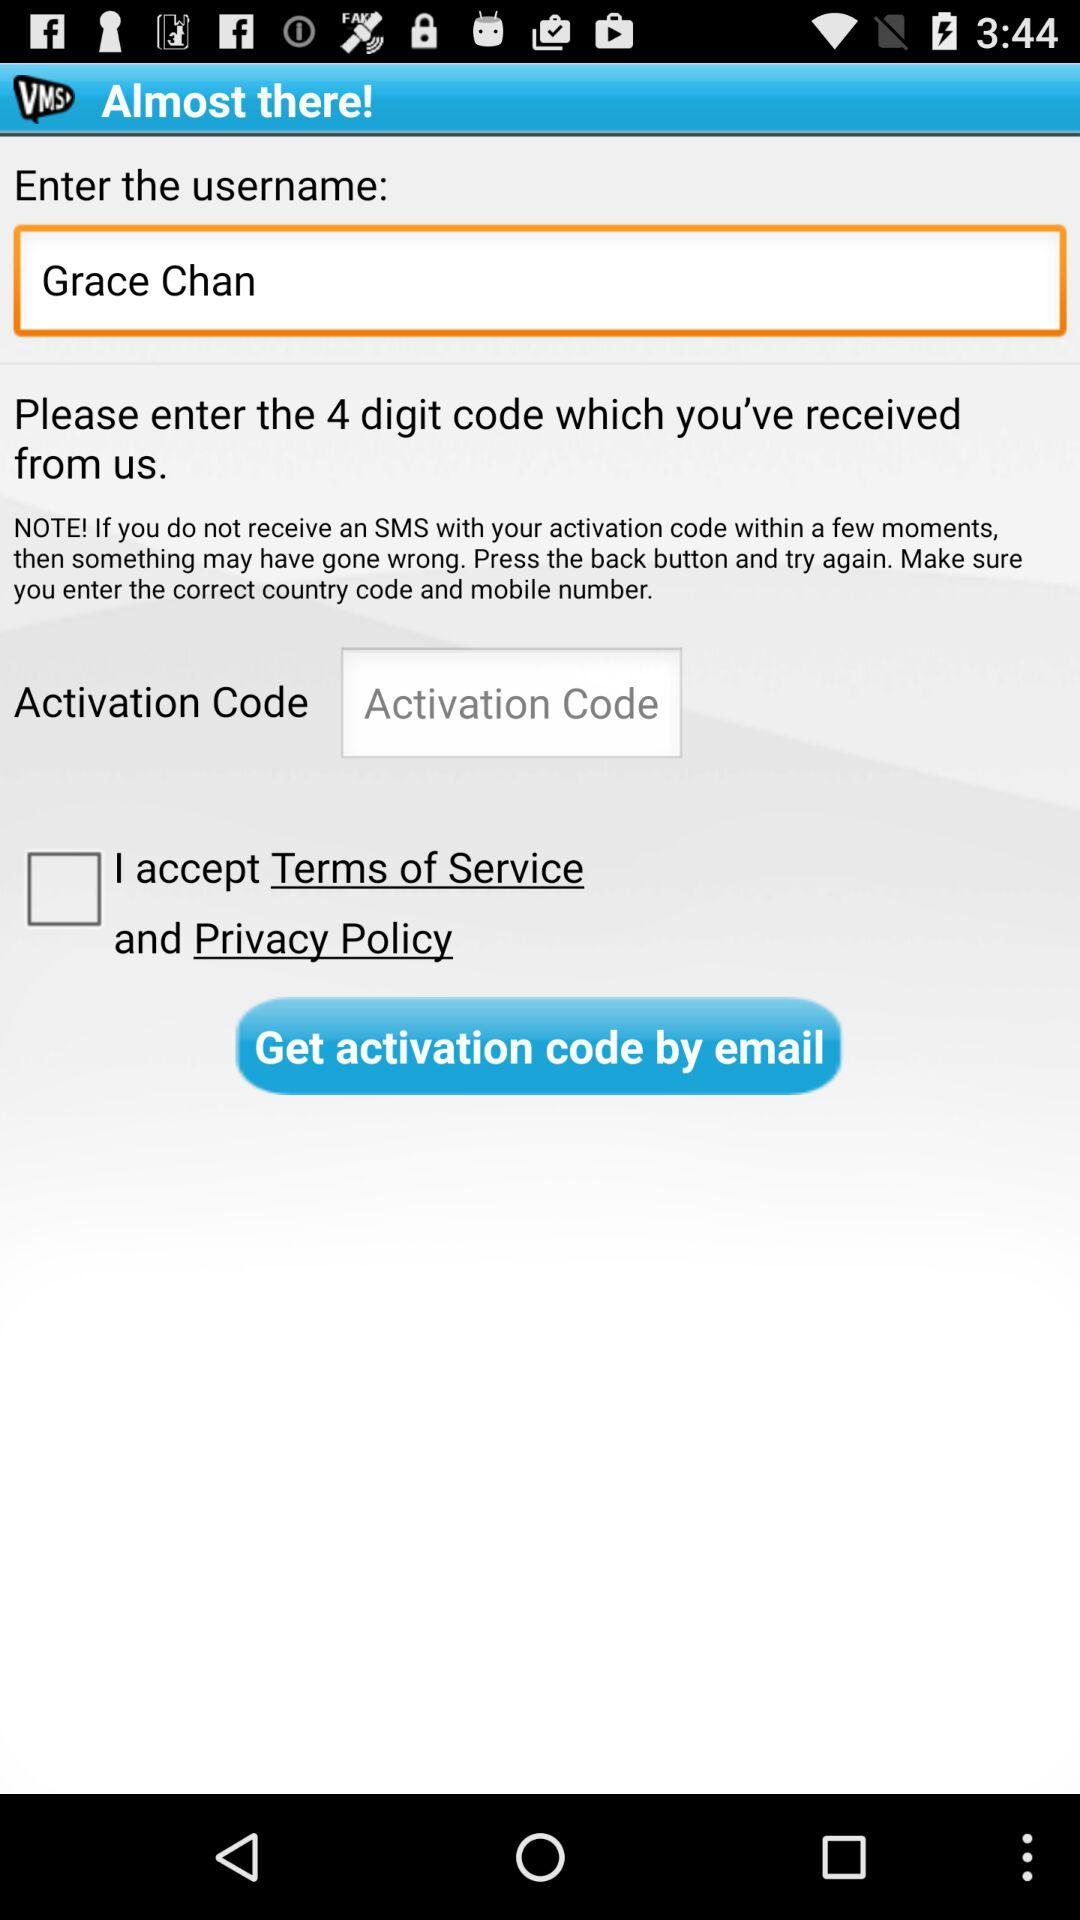How many registration steps in total are there? There are 2 registration steps in total. 